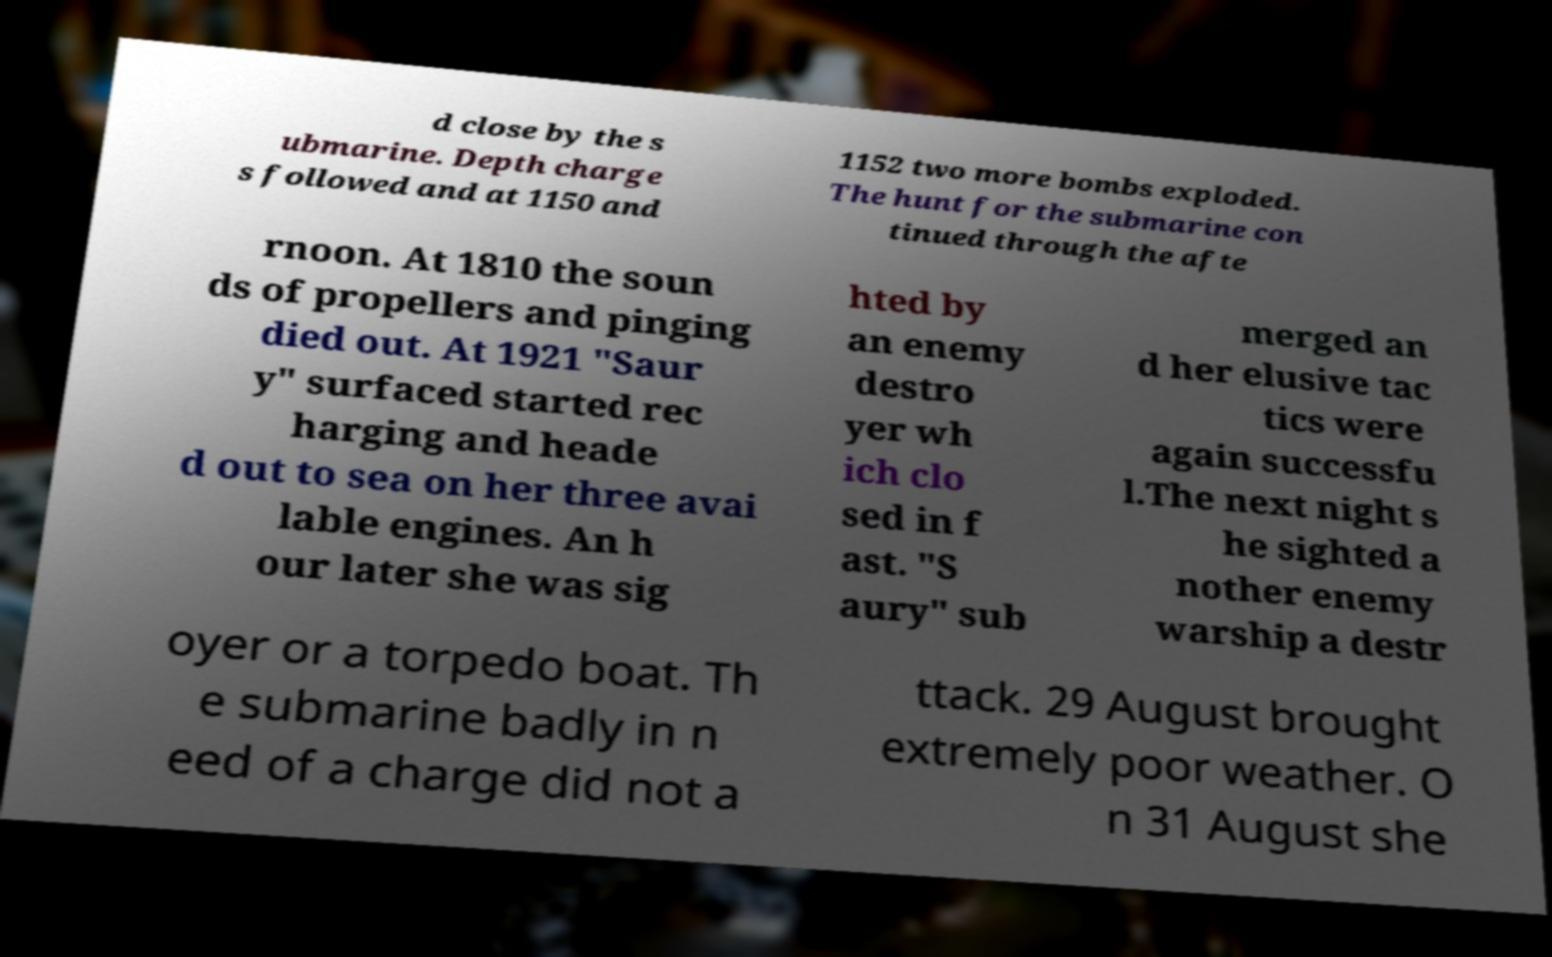Can you accurately transcribe the text from the provided image for me? d close by the s ubmarine. Depth charge s followed and at 1150 and 1152 two more bombs exploded. The hunt for the submarine con tinued through the afte rnoon. At 1810 the soun ds of propellers and pinging died out. At 1921 "Saur y" surfaced started rec harging and heade d out to sea on her three avai lable engines. An h our later she was sig hted by an enemy destro yer wh ich clo sed in f ast. "S aury" sub merged an d her elusive tac tics were again successfu l.The next night s he sighted a nother enemy warship a destr oyer or a torpedo boat. Th e submarine badly in n eed of a charge did not a ttack. 29 August brought extremely poor weather. O n 31 August she 